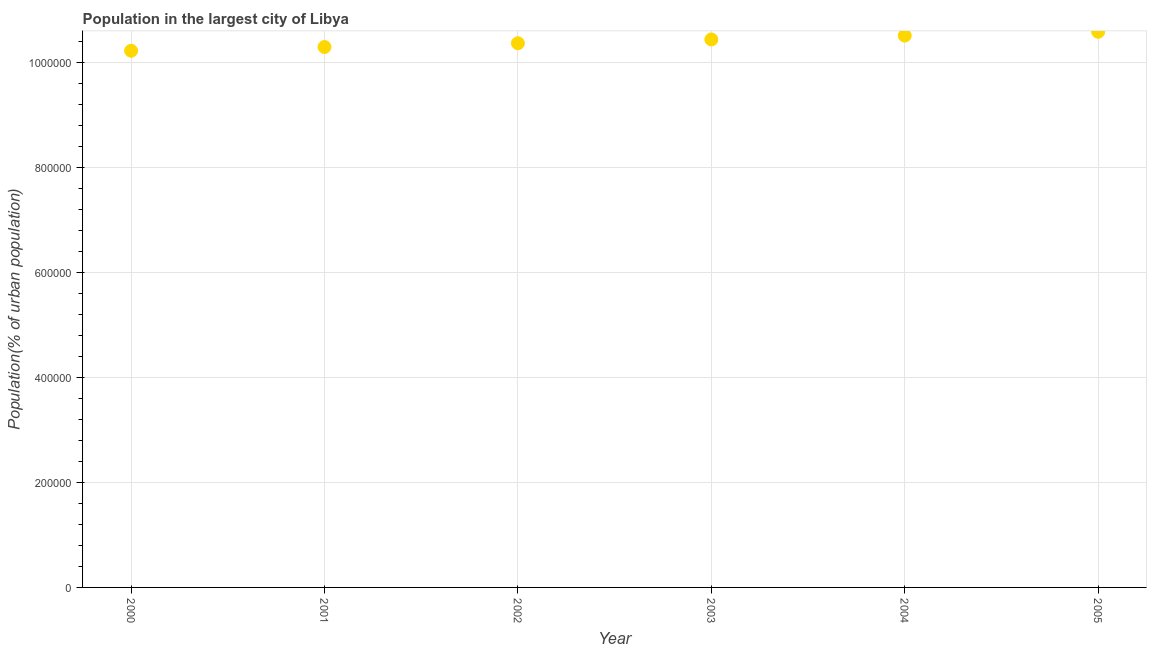What is the population in largest city in 2001?
Offer a terse response. 1.03e+06. Across all years, what is the maximum population in largest city?
Provide a succinct answer. 1.06e+06. Across all years, what is the minimum population in largest city?
Make the answer very short. 1.02e+06. In which year was the population in largest city minimum?
Give a very brief answer. 2000. What is the sum of the population in largest city?
Your response must be concise. 6.24e+06. What is the difference between the population in largest city in 2003 and 2005?
Offer a terse response. -1.46e+04. What is the average population in largest city per year?
Ensure brevity in your answer.  1.04e+06. What is the median population in largest city?
Keep it short and to the point. 1.04e+06. What is the ratio of the population in largest city in 2000 to that in 2003?
Offer a terse response. 0.98. What is the difference between the highest and the second highest population in largest city?
Provide a short and direct response. 7314. Is the sum of the population in largest city in 2002 and 2003 greater than the maximum population in largest city across all years?
Offer a terse response. Yes. What is the difference between the highest and the lowest population in largest city?
Your answer should be very brief. 3.61e+04. How many dotlines are there?
Offer a very short reply. 1. How many years are there in the graph?
Ensure brevity in your answer.  6. What is the title of the graph?
Your answer should be very brief. Population in the largest city of Libya. What is the label or title of the Y-axis?
Keep it short and to the point. Population(% of urban population). What is the Population(% of urban population) in 2000?
Keep it short and to the point. 1.02e+06. What is the Population(% of urban population) in 2001?
Offer a very short reply. 1.03e+06. What is the Population(% of urban population) in 2002?
Your answer should be compact. 1.04e+06. What is the Population(% of urban population) in 2003?
Give a very brief answer. 1.04e+06. What is the Population(% of urban population) in 2004?
Make the answer very short. 1.05e+06. What is the Population(% of urban population) in 2005?
Provide a short and direct response. 1.06e+06. What is the difference between the Population(% of urban population) in 2000 and 2001?
Ensure brevity in your answer.  -7114. What is the difference between the Population(% of urban population) in 2000 and 2002?
Make the answer very short. -1.43e+04. What is the difference between the Population(% of urban population) in 2000 and 2003?
Your answer should be very brief. -2.15e+04. What is the difference between the Population(% of urban population) in 2000 and 2004?
Offer a very short reply. -2.88e+04. What is the difference between the Population(% of urban population) in 2000 and 2005?
Offer a very short reply. -3.61e+04. What is the difference between the Population(% of urban population) in 2001 and 2002?
Your response must be concise. -7173. What is the difference between the Population(% of urban population) in 2001 and 2003?
Your response must be concise. -1.44e+04. What is the difference between the Population(% of urban population) in 2001 and 2004?
Your response must be concise. -2.17e+04. What is the difference between the Population(% of urban population) in 2001 and 2005?
Offer a very short reply. -2.90e+04. What is the difference between the Population(% of urban population) in 2002 and 2003?
Make the answer very short. -7223. What is the difference between the Population(% of urban population) in 2002 and 2004?
Offer a terse response. -1.45e+04. What is the difference between the Population(% of urban population) in 2002 and 2005?
Offer a very short reply. -2.18e+04. What is the difference between the Population(% of urban population) in 2003 and 2004?
Give a very brief answer. -7284. What is the difference between the Population(% of urban population) in 2003 and 2005?
Give a very brief answer. -1.46e+04. What is the difference between the Population(% of urban population) in 2004 and 2005?
Give a very brief answer. -7314. What is the ratio of the Population(% of urban population) in 2000 to that in 2001?
Your answer should be very brief. 0.99. What is the ratio of the Population(% of urban population) in 2000 to that in 2002?
Offer a very short reply. 0.99. What is the ratio of the Population(% of urban population) in 2000 to that in 2003?
Provide a succinct answer. 0.98. What is the ratio of the Population(% of urban population) in 2001 to that in 2003?
Make the answer very short. 0.99. What is the ratio of the Population(% of urban population) in 2001 to that in 2004?
Provide a succinct answer. 0.98. What is the ratio of the Population(% of urban population) in 2002 to that in 2003?
Your answer should be compact. 0.99. What is the ratio of the Population(% of urban population) in 2002 to that in 2004?
Your answer should be very brief. 0.99. What is the ratio of the Population(% of urban population) in 2002 to that in 2005?
Offer a very short reply. 0.98. What is the ratio of the Population(% of urban population) in 2003 to that in 2004?
Make the answer very short. 0.99. What is the ratio of the Population(% of urban population) in 2003 to that in 2005?
Ensure brevity in your answer.  0.99. 